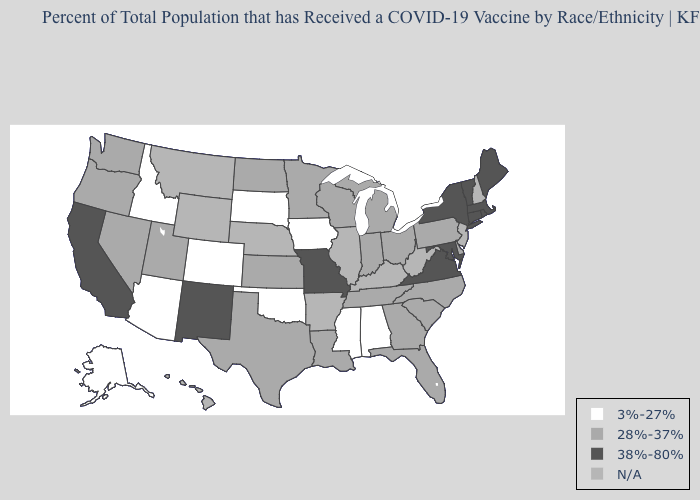What is the value of Hawaii?
Give a very brief answer. N/A. Name the states that have a value in the range 3%-27%?
Short answer required. Alabama, Alaska, Arizona, Colorado, Idaho, Iowa, Mississippi, Oklahoma, South Dakota. Among the states that border West Virginia , does Ohio have the highest value?
Concise answer only. No. Name the states that have a value in the range 3%-27%?
Concise answer only. Alabama, Alaska, Arizona, Colorado, Idaho, Iowa, Mississippi, Oklahoma, South Dakota. Among the states that border New Mexico , which have the lowest value?
Answer briefly. Arizona, Colorado, Oklahoma. What is the value of Utah?
Give a very brief answer. 28%-37%. What is the highest value in states that border Wyoming?
Concise answer only. 28%-37%. What is the value of Wisconsin?
Short answer required. 28%-37%. What is the highest value in the South ?
Write a very short answer. 38%-80%. Among the states that border Minnesota , does North Dakota have the lowest value?
Be succinct. No. What is the value of New Hampshire?
Short answer required. N/A. Which states have the highest value in the USA?
Write a very short answer. California, Connecticut, Maine, Maryland, Massachusetts, Missouri, New Mexico, New York, Rhode Island, Vermont, Virginia. What is the value of Delaware?
Keep it brief. 28%-37%. 